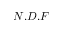Convert formula to latex. <formula><loc_0><loc_0><loc_500><loc_500>N . D . F</formula> 